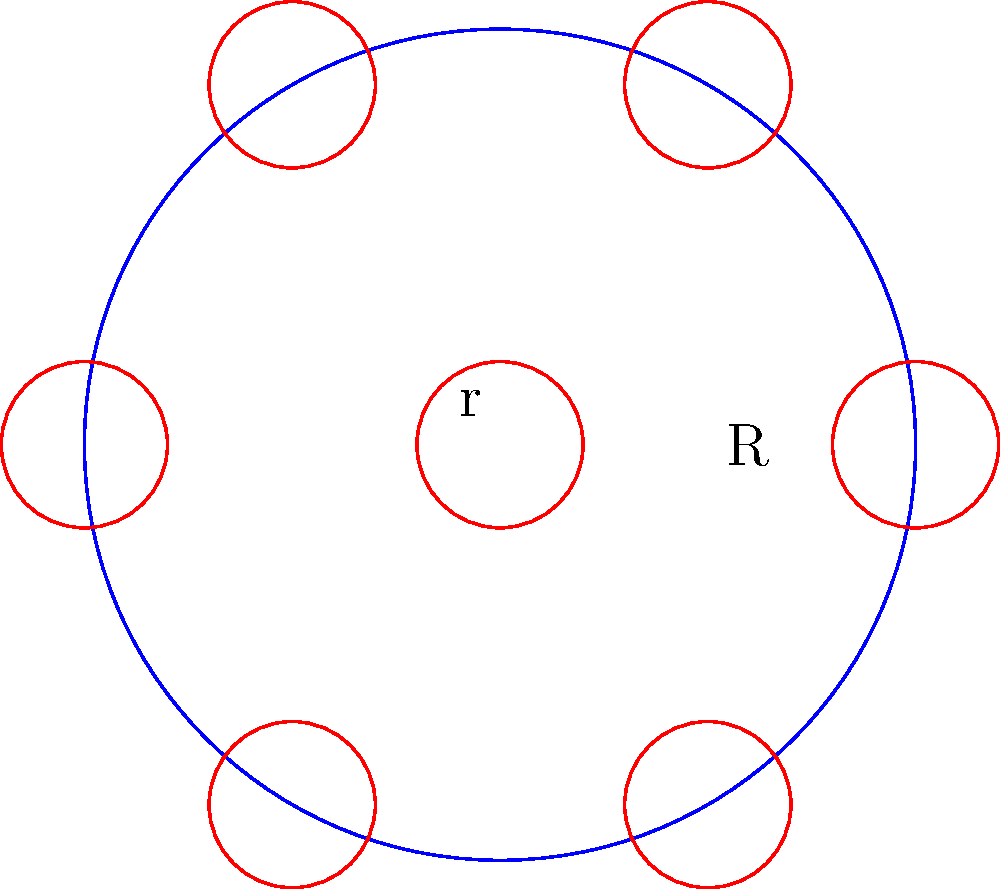In a circular designated parking area for electric scooters, you want to maximize the number of scooters that can be parked. The parking area has a radius of R, and each scooter occupies a circular space with radius r. Assuming one scooter is placed in the center and the others are arranged around it in a circular pattern, what is the maximum number of scooters that can be parked in this area, expressed in terms of R and r? To solve this problem, we'll follow these steps:

1) One scooter is placed in the center of the parking area.

2) The remaining scooters will form a ring around the central scooter. The centers of these scooters will form a regular polygon.

3) The radius of the circle passing through the centers of the outer scooters is $R - r$. This is because the outer scooters must be fully contained within the parking area.

4) The distance between the centers of adjacent scooters in the outer ring is $2r$. This ensures the scooters don't overlap.

5) The number of scooters that can fit in the outer ring is determined by how many chords of length $2r$ can fit around the circle with radius $R - r$.

6) This is given by the formula: $n = \left\lfloor\frac{2\pi(R-r)}{2r}\right\rfloor = \left\lfloor\frac{\pi(R-r)}{r}\right\rfloor$

   Where $\lfloor \cdot \rfloor$ denotes the floor function (rounding down to the nearest integer).

7) Adding 1 for the central scooter, the total number of scooters is:

   $N = 1 + \left\lfloor\frac{\pi(R-r)}{r}\right\rfloor$

This formula gives the maximum number of scooters that can be parked in the circular area.
Answer: $1 + \left\lfloor\frac{\pi(R-r)}{r}\right\rfloor$ 